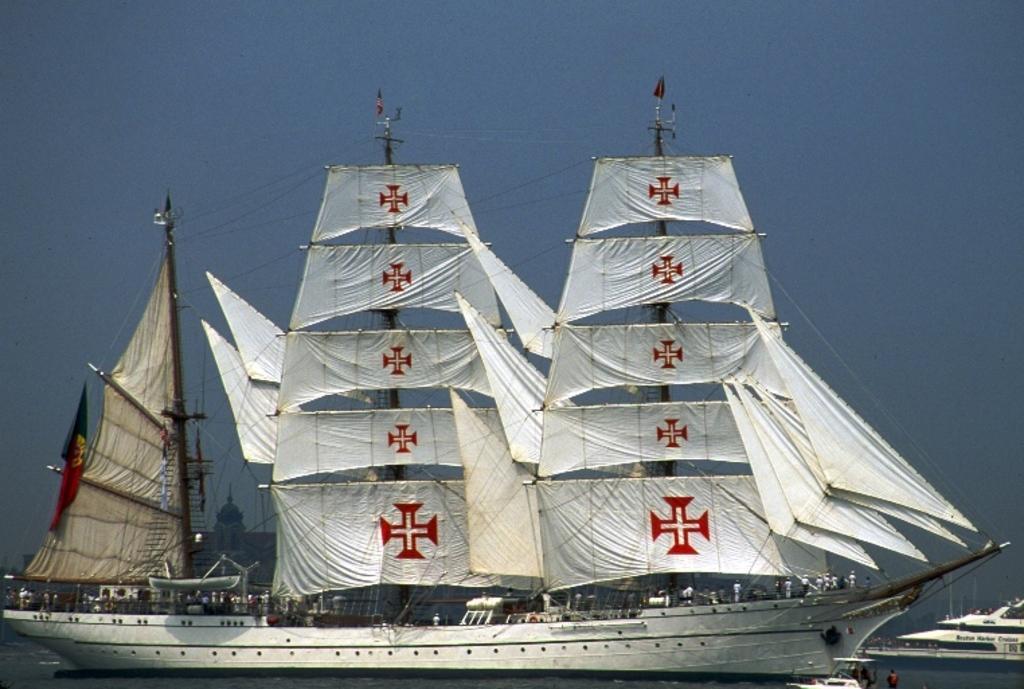How would you summarize this image in a sentence or two? Here I can see two ships and a boat on the water. On the boat and the ship I can see people are standing. On the top of the ship there are few poles to which white color clothes her attached with the ropes. On the top of the image I can see the sky. 